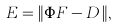<formula> <loc_0><loc_0><loc_500><loc_500>E = \| { \Phi } { F } - { D } \, \| ,</formula> 